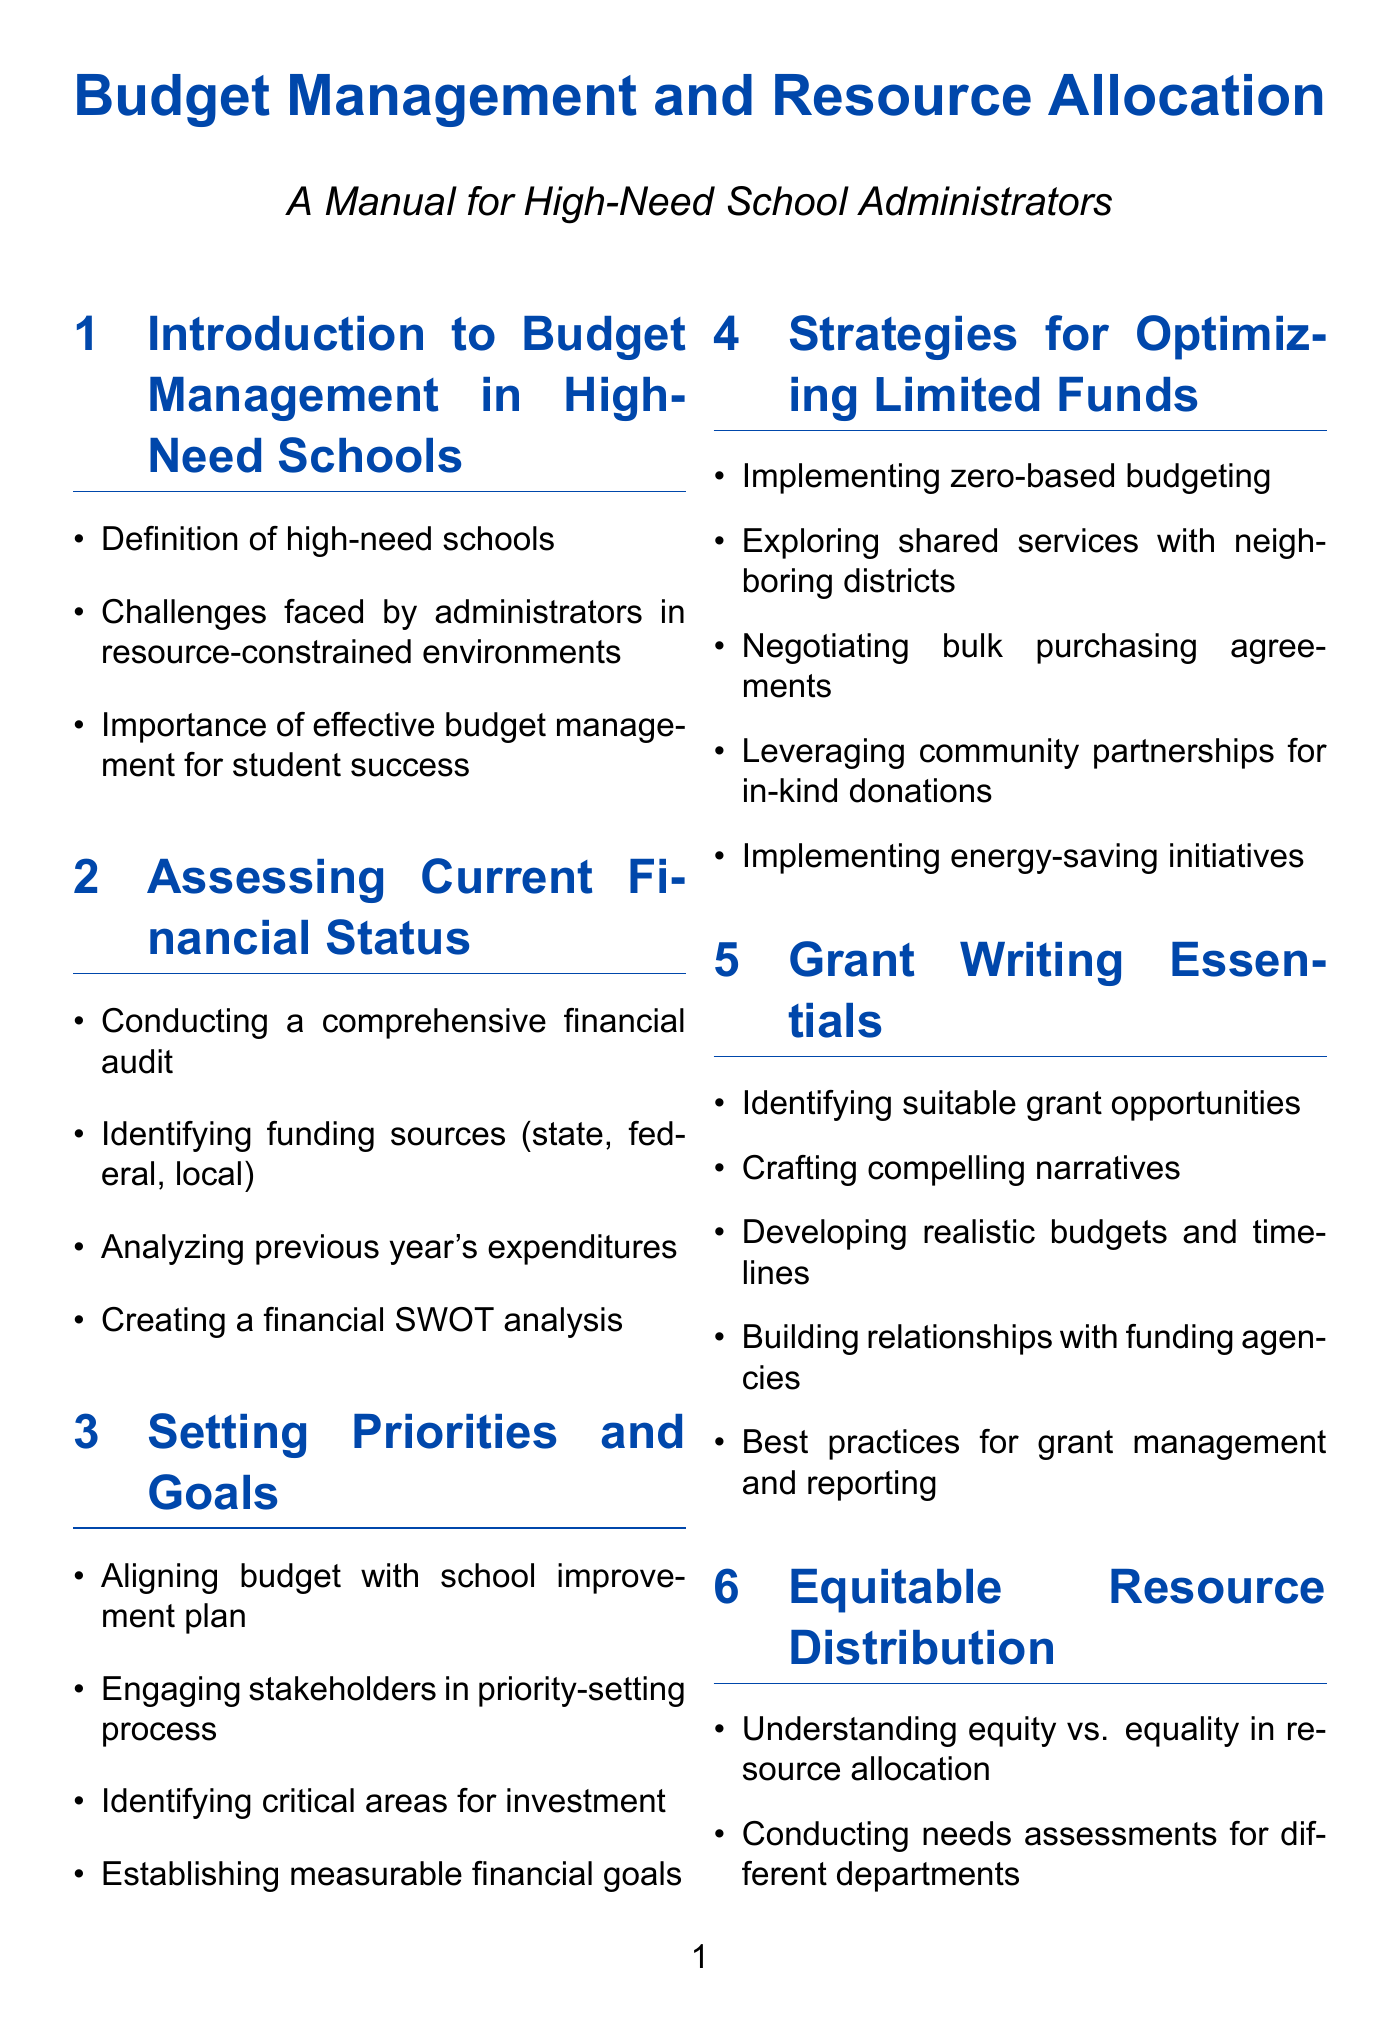what is the title of the manual? The title is the main heading of the document that summarizes its purpose and content.
Answer: Budget Management and Resource Allocation what are the two types of initiatives listed under "Strategies for Optimizing Limited Funds"? The question focuses on retrieving specific items listed in the corresponding section of the document.
Answer: energy-saving initiatives, shared services with neighboring districts what is a critical area for investment mentioned in the "Setting Priorities and Goals" section? This question asks for specific critical areas as outlined in the manual, which provide focus for budget planning.
Answer: technology what does "BYOD" stand for in the "Technology Integration and Cost-Effective Solutions" section? This question seeks a definition of the abbreviation mentioned in the document.
Answer: Bring Your Own Device which section discusses legal and ethical considerations? This question requests the specific section title related to legal compliance and ethical issues in budgeting.
Answer: Legal and Ethical Considerations how often should budget reviews be conducted according to the manual? The question examines the recommended frequency of budget reviews outlined in the relevant section.
Answer: monthly name one community engagement strategy mentioned in the manual. This question prompts for a specific strategy aimed at involving the community in financial initiatives from the corresponding section.
Answer: crowdfunding initiatives what type of funding opportunities should be identified in the "Grant Writing Essentials"? This question targets specific funding types that should be focused on in the grant writing section of the manual.
Answer: Title I, IDEA how is equity defined in the context of the manual? This question requires understanding the distinction made between terms discussed in the "Equitable Resource Distribution" section.
Answer: Understanding equity vs. equality in resource allocation 